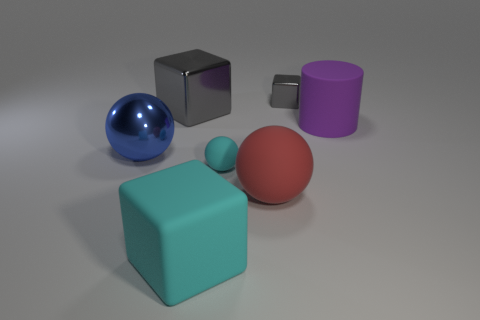Subtract all rubber blocks. How many blocks are left? 2 Subtract all red balls. How many balls are left? 2 Add 1 blue metal balls. How many objects exist? 8 Subtract all cubes. How many objects are left? 4 Subtract all purple balls. How many gray blocks are left? 2 Subtract all small gray things. Subtract all large rubber spheres. How many objects are left? 5 Add 7 small matte balls. How many small matte balls are left? 8 Add 6 purple shiny balls. How many purple shiny balls exist? 6 Subtract 0 green cylinders. How many objects are left? 7 Subtract all gray cylinders. Subtract all yellow balls. How many cylinders are left? 1 